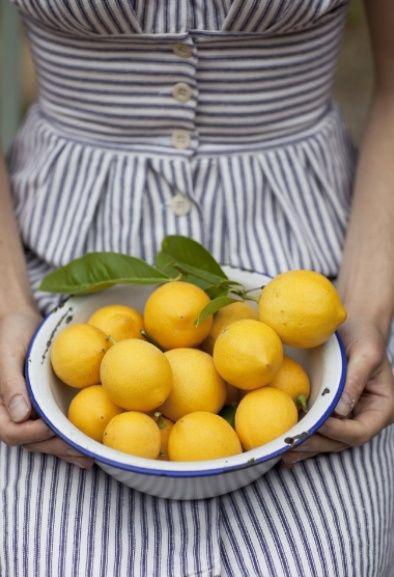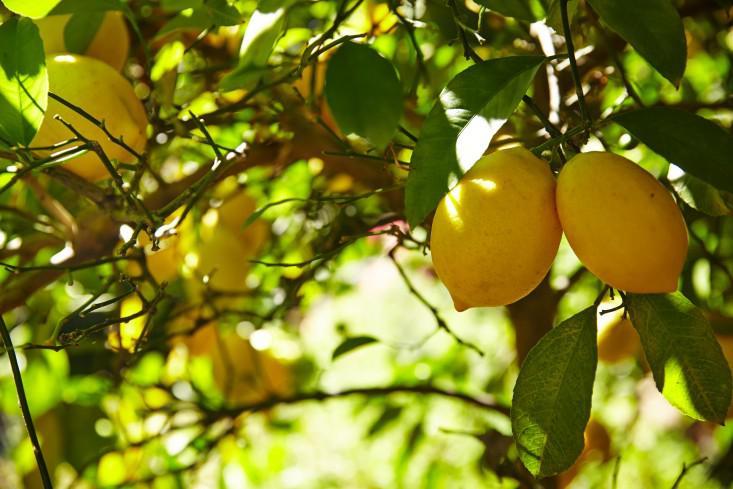The first image is the image on the left, the second image is the image on the right. Analyze the images presented: Is the assertion "One image shows multiple lemons still on their tree, while the other image shows multiple lemons that have been picked from the tree but still have a few leaves with them." valid? Answer yes or no. Yes. 